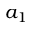Convert formula to latex. <formula><loc_0><loc_0><loc_500><loc_500>a _ { 1 }</formula> 